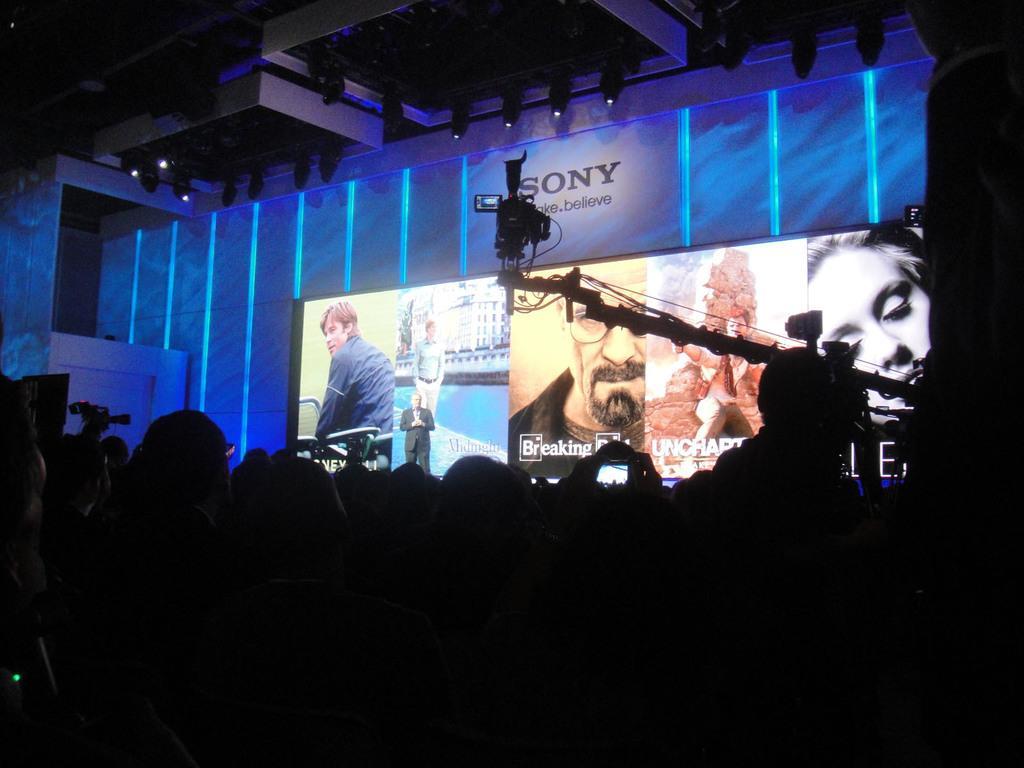Could you give a brief overview of what you see in this image? In this picture there is a person standing on the stage. At the back there is a screen. On the right side of the image there is a camera. In the foreground there are group of people. At the top there are lights. At the back there is a text on the wall and there are pictures of man and woman on the screen. 